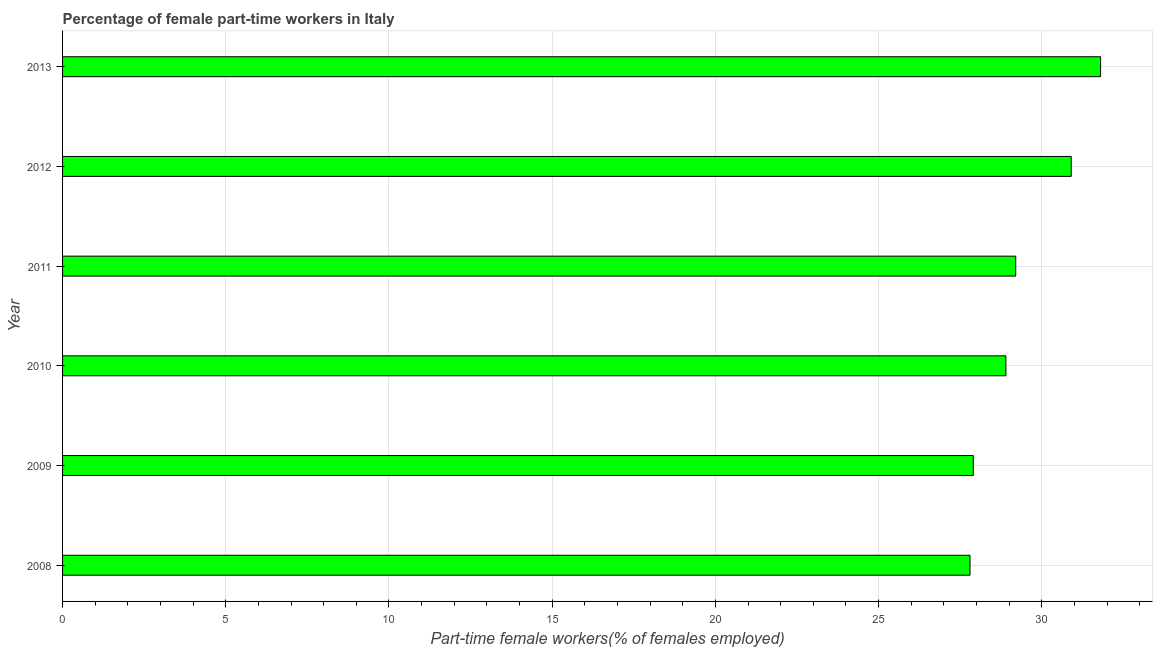Does the graph contain grids?
Keep it short and to the point. Yes. What is the title of the graph?
Your response must be concise. Percentage of female part-time workers in Italy. What is the label or title of the X-axis?
Ensure brevity in your answer.  Part-time female workers(% of females employed). What is the label or title of the Y-axis?
Your answer should be compact. Year. What is the percentage of part-time female workers in 2011?
Offer a terse response. 29.2. Across all years, what is the maximum percentage of part-time female workers?
Make the answer very short. 31.8. Across all years, what is the minimum percentage of part-time female workers?
Ensure brevity in your answer.  27.8. What is the sum of the percentage of part-time female workers?
Provide a short and direct response. 176.5. What is the average percentage of part-time female workers per year?
Ensure brevity in your answer.  29.42. What is the median percentage of part-time female workers?
Ensure brevity in your answer.  29.05. Do a majority of the years between 2013 and 2012 (inclusive) have percentage of part-time female workers greater than 27 %?
Your answer should be very brief. No. Is the difference between the percentage of part-time female workers in 2008 and 2009 greater than the difference between any two years?
Your response must be concise. No. What is the difference between the highest and the second highest percentage of part-time female workers?
Provide a succinct answer. 0.9. Is the sum of the percentage of part-time female workers in 2008 and 2009 greater than the maximum percentage of part-time female workers across all years?
Provide a short and direct response. Yes. In how many years, is the percentage of part-time female workers greater than the average percentage of part-time female workers taken over all years?
Keep it short and to the point. 2. How many bars are there?
Keep it short and to the point. 6. Are all the bars in the graph horizontal?
Your answer should be very brief. Yes. What is the Part-time female workers(% of females employed) in 2008?
Keep it short and to the point. 27.8. What is the Part-time female workers(% of females employed) of 2009?
Your answer should be compact. 27.9. What is the Part-time female workers(% of females employed) in 2010?
Make the answer very short. 28.9. What is the Part-time female workers(% of females employed) in 2011?
Provide a short and direct response. 29.2. What is the Part-time female workers(% of females employed) in 2012?
Provide a succinct answer. 30.9. What is the Part-time female workers(% of females employed) in 2013?
Ensure brevity in your answer.  31.8. What is the difference between the Part-time female workers(% of females employed) in 2008 and 2009?
Provide a succinct answer. -0.1. What is the difference between the Part-time female workers(% of females employed) in 2008 and 2010?
Make the answer very short. -1.1. What is the difference between the Part-time female workers(% of females employed) in 2008 and 2011?
Your answer should be compact. -1.4. What is the difference between the Part-time female workers(% of females employed) in 2008 and 2012?
Offer a very short reply. -3.1. What is the difference between the Part-time female workers(% of females employed) in 2009 and 2010?
Offer a very short reply. -1. What is the difference between the Part-time female workers(% of females employed) in 2010 and 2011?
Your answer should be very brief. -0.3. What is the difference between the Part-time female workers(% of females employed) in 2010 and 2012?
Offer a terse response. -2. What is the difference between the Part-time female workers(% of females employed) in 2011 and 2012?
Ensure brevity in your answer.  -1.7. What is the difference between the Part-time female workers(% of females employed) in 2012 and 2013?
Provide a succinct answer. -0.9. What is the ratio of the Part-time female workers(% of females employed) in 2008 to that in 2009?
Ensure brevity in your answer.  1. What is the ratio of the Part-time female workers(% of females employed) in 2008 to that in 2013?
Make the answer very short. 0.87. What is the ratio of the Part-time female workers(% of females employed) in 2009 to that in 2010?
Give a very brief answer. 0.96. What is the ratio of the Part-time female workers(% of females employed) in 2009 to that in 2011?
Provide a short and direct response. 0.95. What is the ratio of the Part-time female workers(% of females employed) in 2009 to that in 2012?
Your answer should be very brief. 0.9. What is the ratio of the Part-time female workers(% of females employed) in 2009 to that in 2013?
Ensure brevity in your answer.  0.88. What is the ratio of the Part-time female workers(% of females employed) in 2010 to that in 2012?
Your answer should be compact. 0.94. What is the ratio of the Part-time female workers(% of females employed) in 2010 to that in 2013?
Your answer should be very brief. 0.91. What is the ratio of the Part-time female workers(% of females employed) in 2011 to that in 2012?
Make the answer very short. 0.94. What is the ratio of the Part-time female workers(% of females employed) in 2011 to that in 2013?
Give a very brief answer. 0.92. 